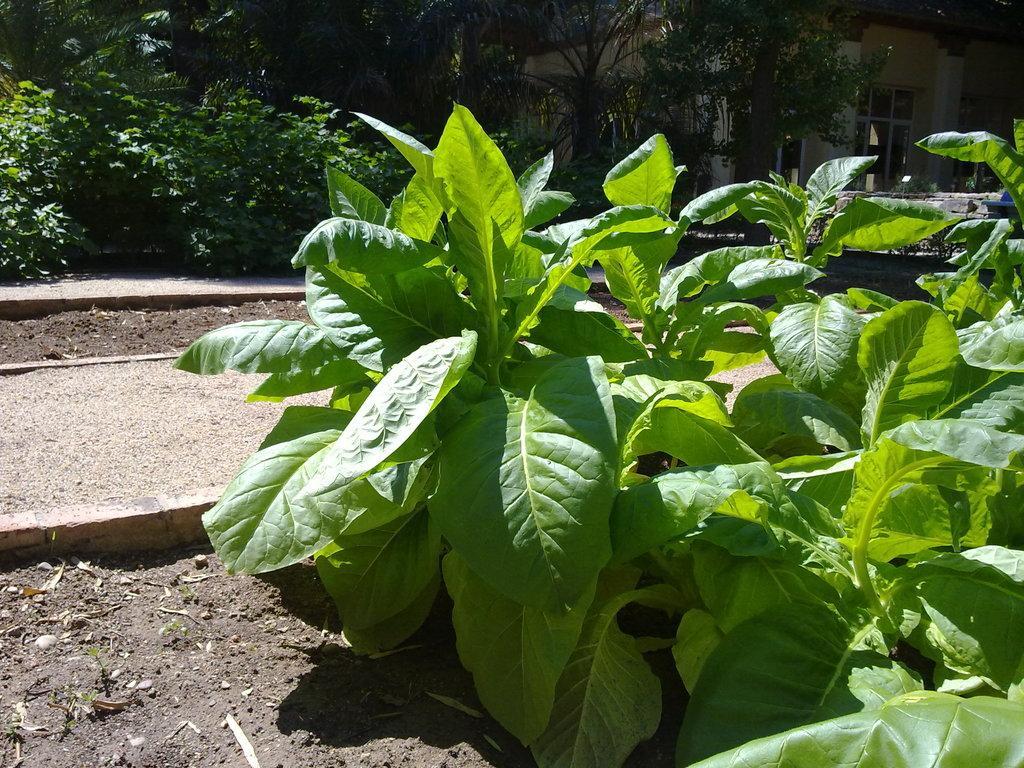Could you give a brief overview of what you see in this image? In the foreground of the picture there are plants, soil and stones. On the left there are pavement and soil. In the background there are plants, trees, door and a building. 